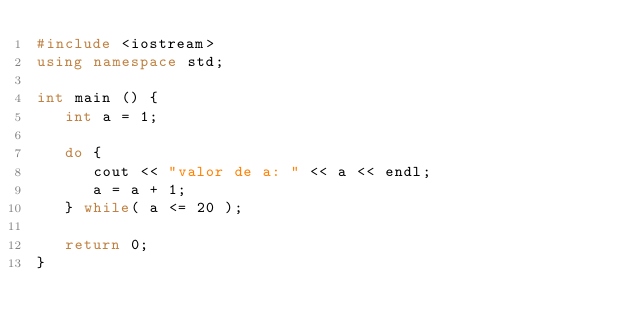Convert code to text. <code><loc_0><loc_0><loc_500><loc_500><_C++_>#include <iostream>
using namespace std;
 
int main () {
   int a = 1;

   do {
      cout << "valor de a: " << a << endl;
      a = a + 1;
   } while( a <= 20 );
 
   return 0;
}


</code> 